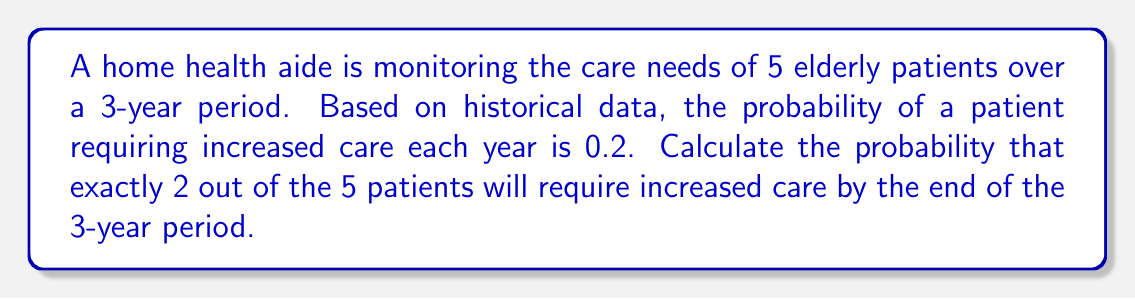Give your solution to this math problem. To solve this problem, we can use the binomial probability formula, as we are dealing with a fixed number of independent trials (5 patients) with two possible outcomes (requiring increased care or not) and a constant probability of success.

The binomial probability formula is:

$$P(X = k) = \binom{n}{k} p^k (1-p)^{n-k}$$

Where:
$n$ = number of trials (patients) = 5
$k$ = number of successes (patients requiring increased care) = 2
$p$ = probability of success on a single trial

However, we need to calculate $p$ for the entire 3-year period. The probability of a patient not requiring increased care in one year is $(1 - 0.2) = 0.8$. For three years, it's $0.8^3 = 0.512$. Therefore, the probability of requiring increased care over 3 years is:

$$p = 1 - 0.512 = 0.488$$

Now we can apply the binomial probability formula:

$$P(X = 2) = \binom{5}{2} (0.488)^2 (1-0.488)^{5-2}$$

$$= 10 \cdot (0.488)^2 \cdot (0.512)^3$$

$$= 10 \cdot 0.238144 \cdot 0.134217728$$

$$= 0.319387$$

Therefore, the probability that exactly 2 out of the 5 patients will require increased care by the end of the 3-year period is approximately 0.319387 or 31.94%.
Answer: 0.319387 or 31.94% 